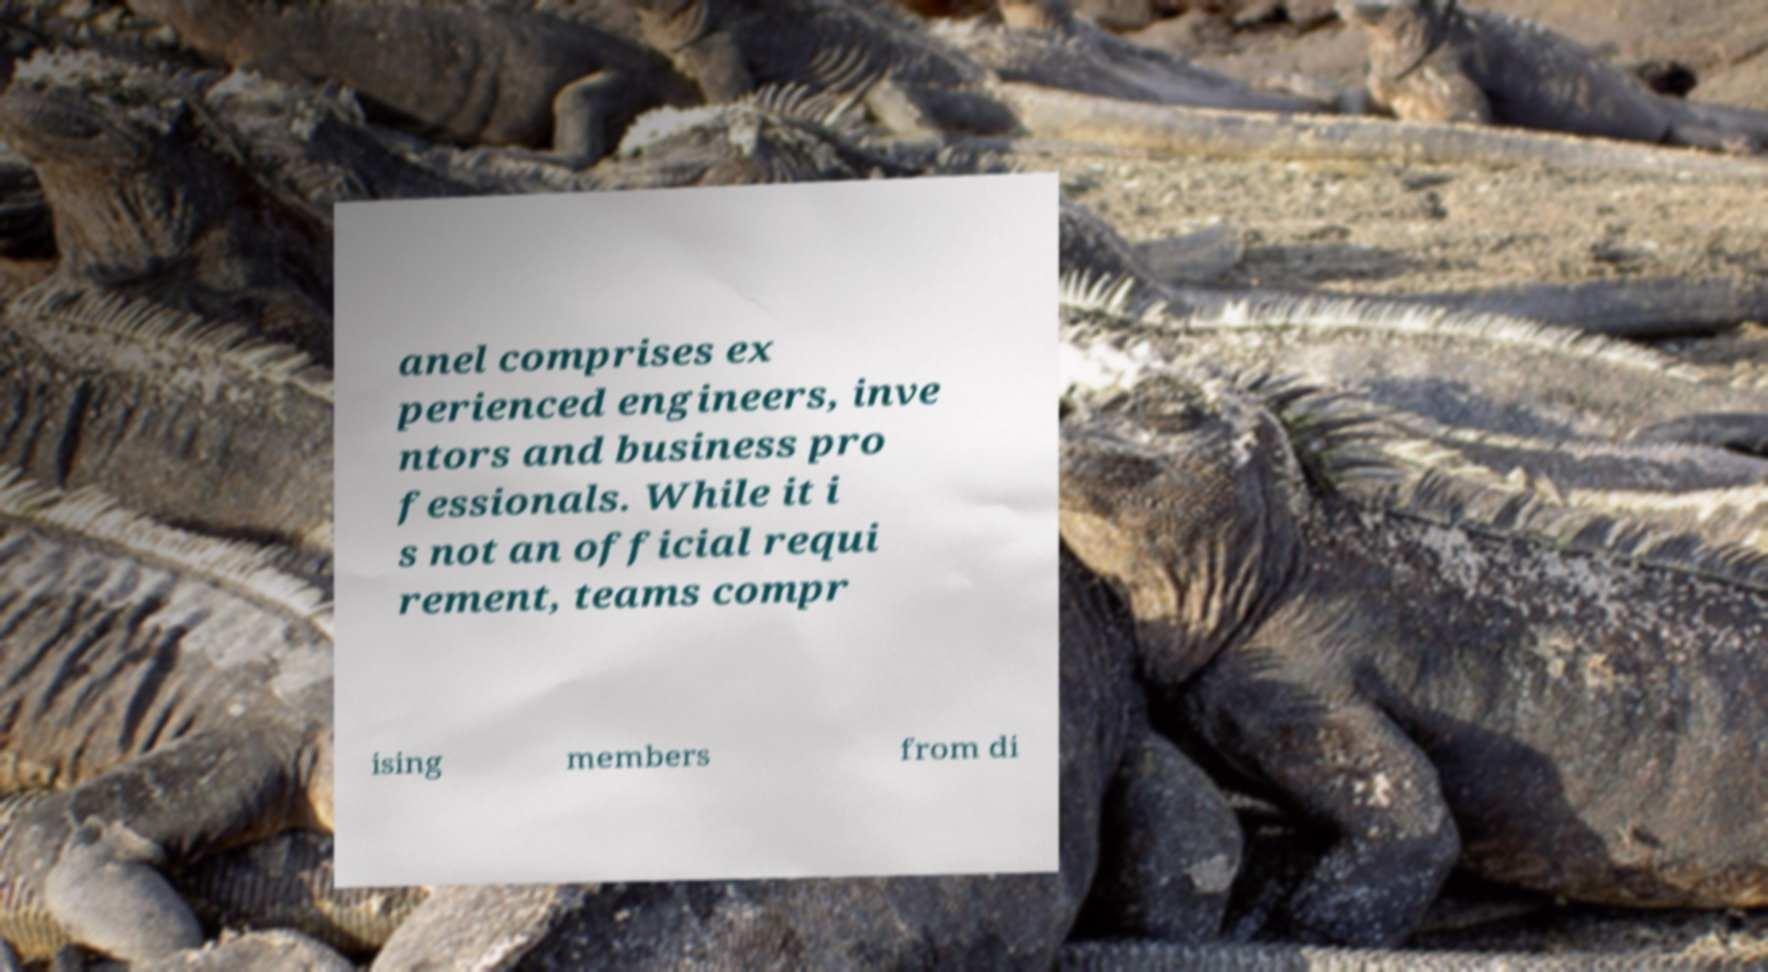Please read and relay the text visible in this image. What does it say? anel comprises ex perienced engineers, inve ntors and business pro fessionals. While it i s not an official requi rement, teams compr ising members from di 